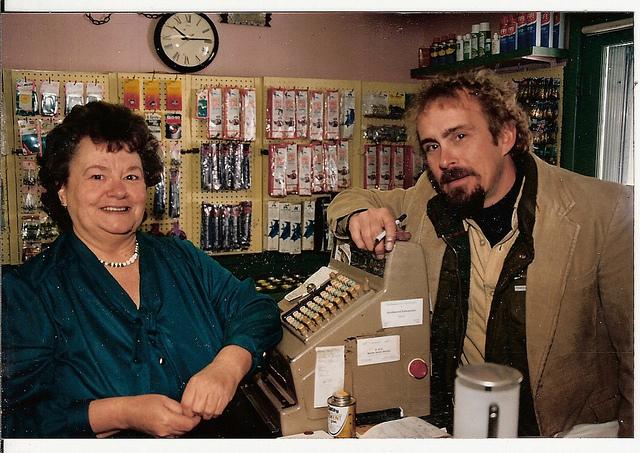What is she doing?
Short answer required. Cashier. What time does the clock say?
Quick response, please. 10:15. Which wrist is the watch on?
Concise answer only. Right. Is this the people's home?
Write a very short answer. No. What is the man writing with?
Quick response, please. Pen. Are the people facing the camera?
Answer briefly. Yes. 